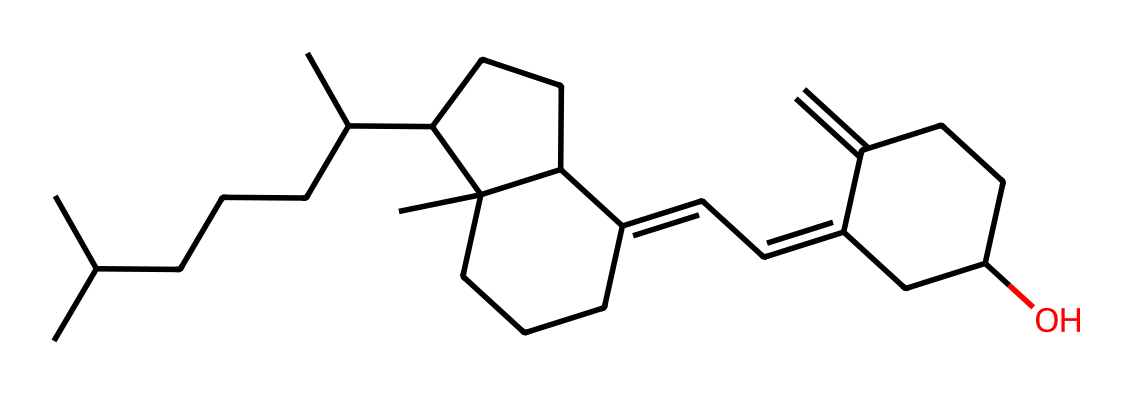What is the primary name of this compound? The provided SMILES represents the chemical structure of Vitamin D3, also known as cholecalciferol. The structure indicates a sterol with specific side chains unique to Vitamin D3.
Answer: Vitamin D3 How many carbon atoms are in the structure? To determine the number of carbon atoms, count each 'C' in the SMILES representation. In total, there are 27 carbon atoms in cholecalciferol's structure.
Answer: 27 What functional group characterizes Vitamin D3? Analyzing the structure shows a hydroxyl (-OH) group which is a key functional group in Vitamin D3. This hydroxyl group contributes to its solubility and biological activity.
Answer: Hydroxyl group How does Vitamin D3 contribute to bone health? Vitamin D3 enhances the absorption of calcium and phosphate in the intestines, which are crucial for bone mineralization and overall bone health. This absorption role directly links it to preventing bone diseases like osteoporosis.
Answer: Calcium absorption What type of compound is Vitamin D3 classified as? Vitamin D3 is classified as a secosteroid, which is a class of steroid molecules that contain a broken ring. This classification is evident from its structure and functional characteristics.
Answer: Secosteroid Which part of Vitamin D3 is essential for its biological activity? The presence of the hydroxyl group (-OH) in Vitamin D3 is essential for its biological activity, as it allows for binding to vitamin D receptors which are crucial for its function in calcium balance.
Answer: Hydroxyl group What is the significance of the double bond in Vitamin D3's structure? The double bond in Vitamin D3's structure is significant because it impacts the molecule's stability, reactivity, and biological function, particularly in its role in activating vitamin D receptors.
Answer: Double bond 